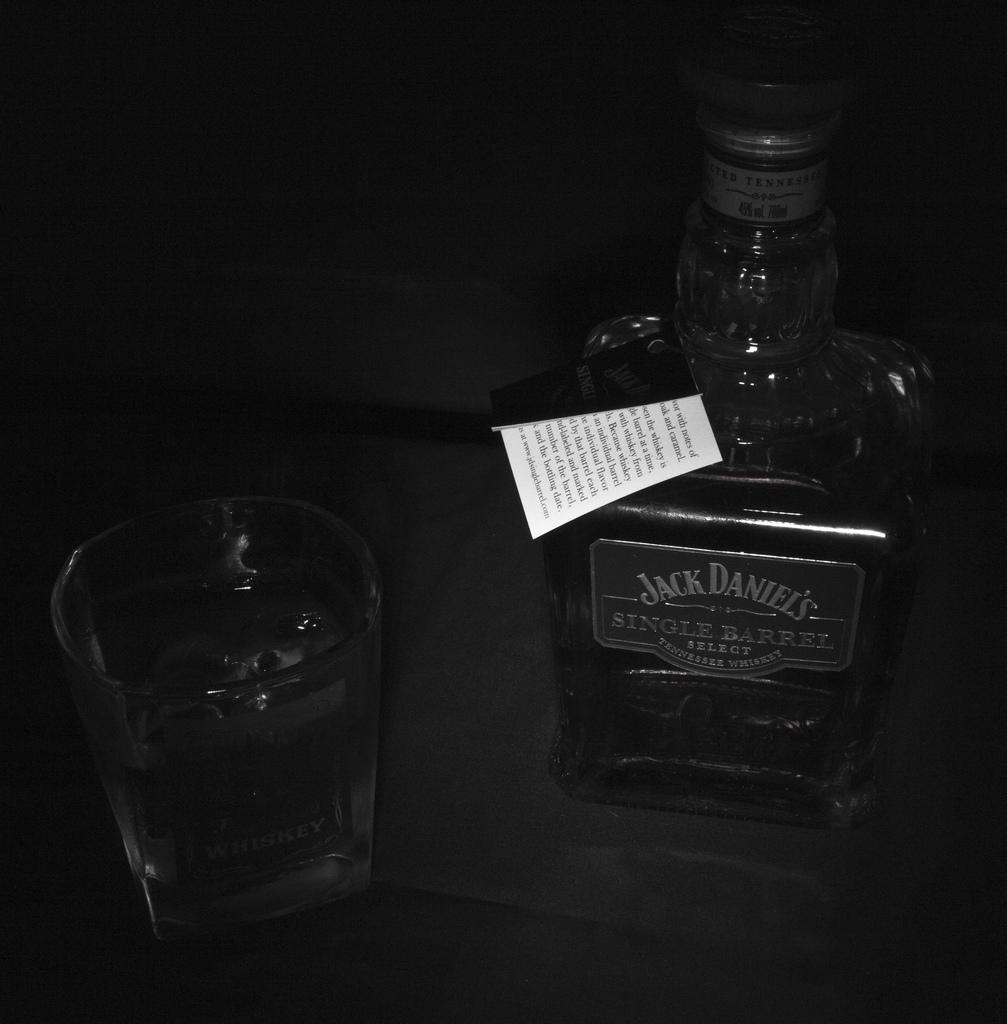What is one of the objects visible in the image? There is a glass in the image. What other object can be seen in the image? There is a bottle in the image. Can you describe the bottle in the image? The bottle has text written on it and a white paper on it. What is written on the white paper? The white paper has text on it. How many kilograms does the top weigh in the image? There is no top present in the image, so it is not possible to determine its weight. 